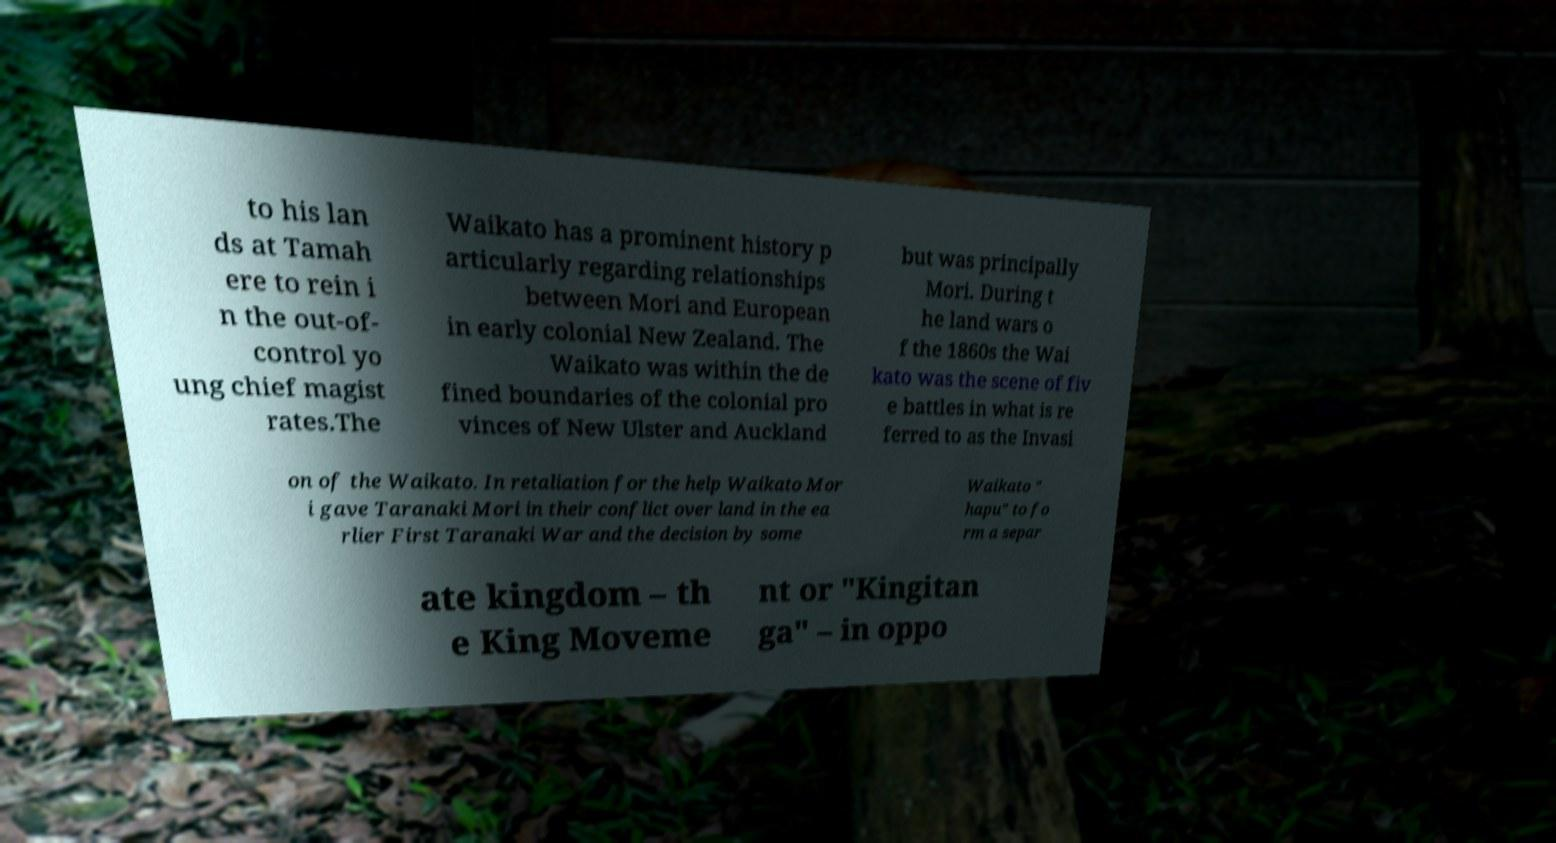What messages or text are displayed in this image? I need them in a readable, typed format. to his lan ds at Tamah ere to rein i n the out-of- control yo ung chief magist rates.The Waikato has a prominent history p articularly regarding relationships between Mori and European in early colonial New Zealand. The Waikato was within the de fined boundaries of the colonial pro vinces of New Ulster and Auckland but was principally Mori. During t he land wars o f the 1860s the Wai kato was the scene of fiv e battles in what is re ferred to as the Invasi on of the Waikato. In retaliation for the help Waikato Mor i gave Taranaki Mori in their conflict over land in the ea rlier First Taranaki War and the decision by some Waikato " hapu" to fo rm a separ ate kingdom – th e King Moveme nt or "Kingitan ga" – in oppo 